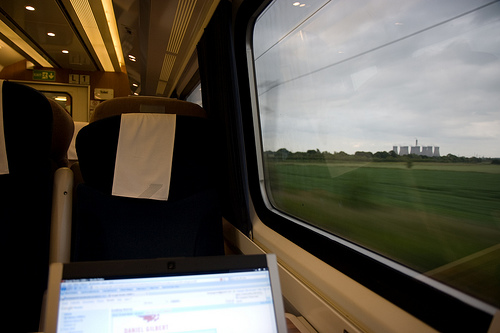<image>
Can you confirm if the chair is behind the laptop? Yes. From this viewpoint, the chair is positioned behind the laptop, with the laptop partially or fully occluding the chair. 